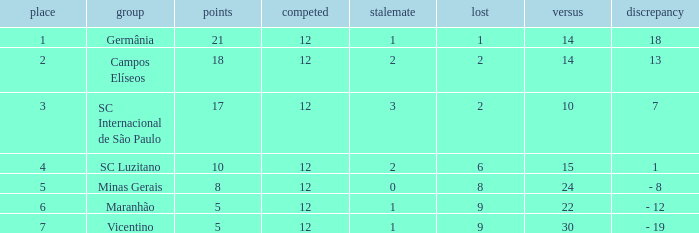What is the sum of drawn that has a played more than 12? 0.0. 